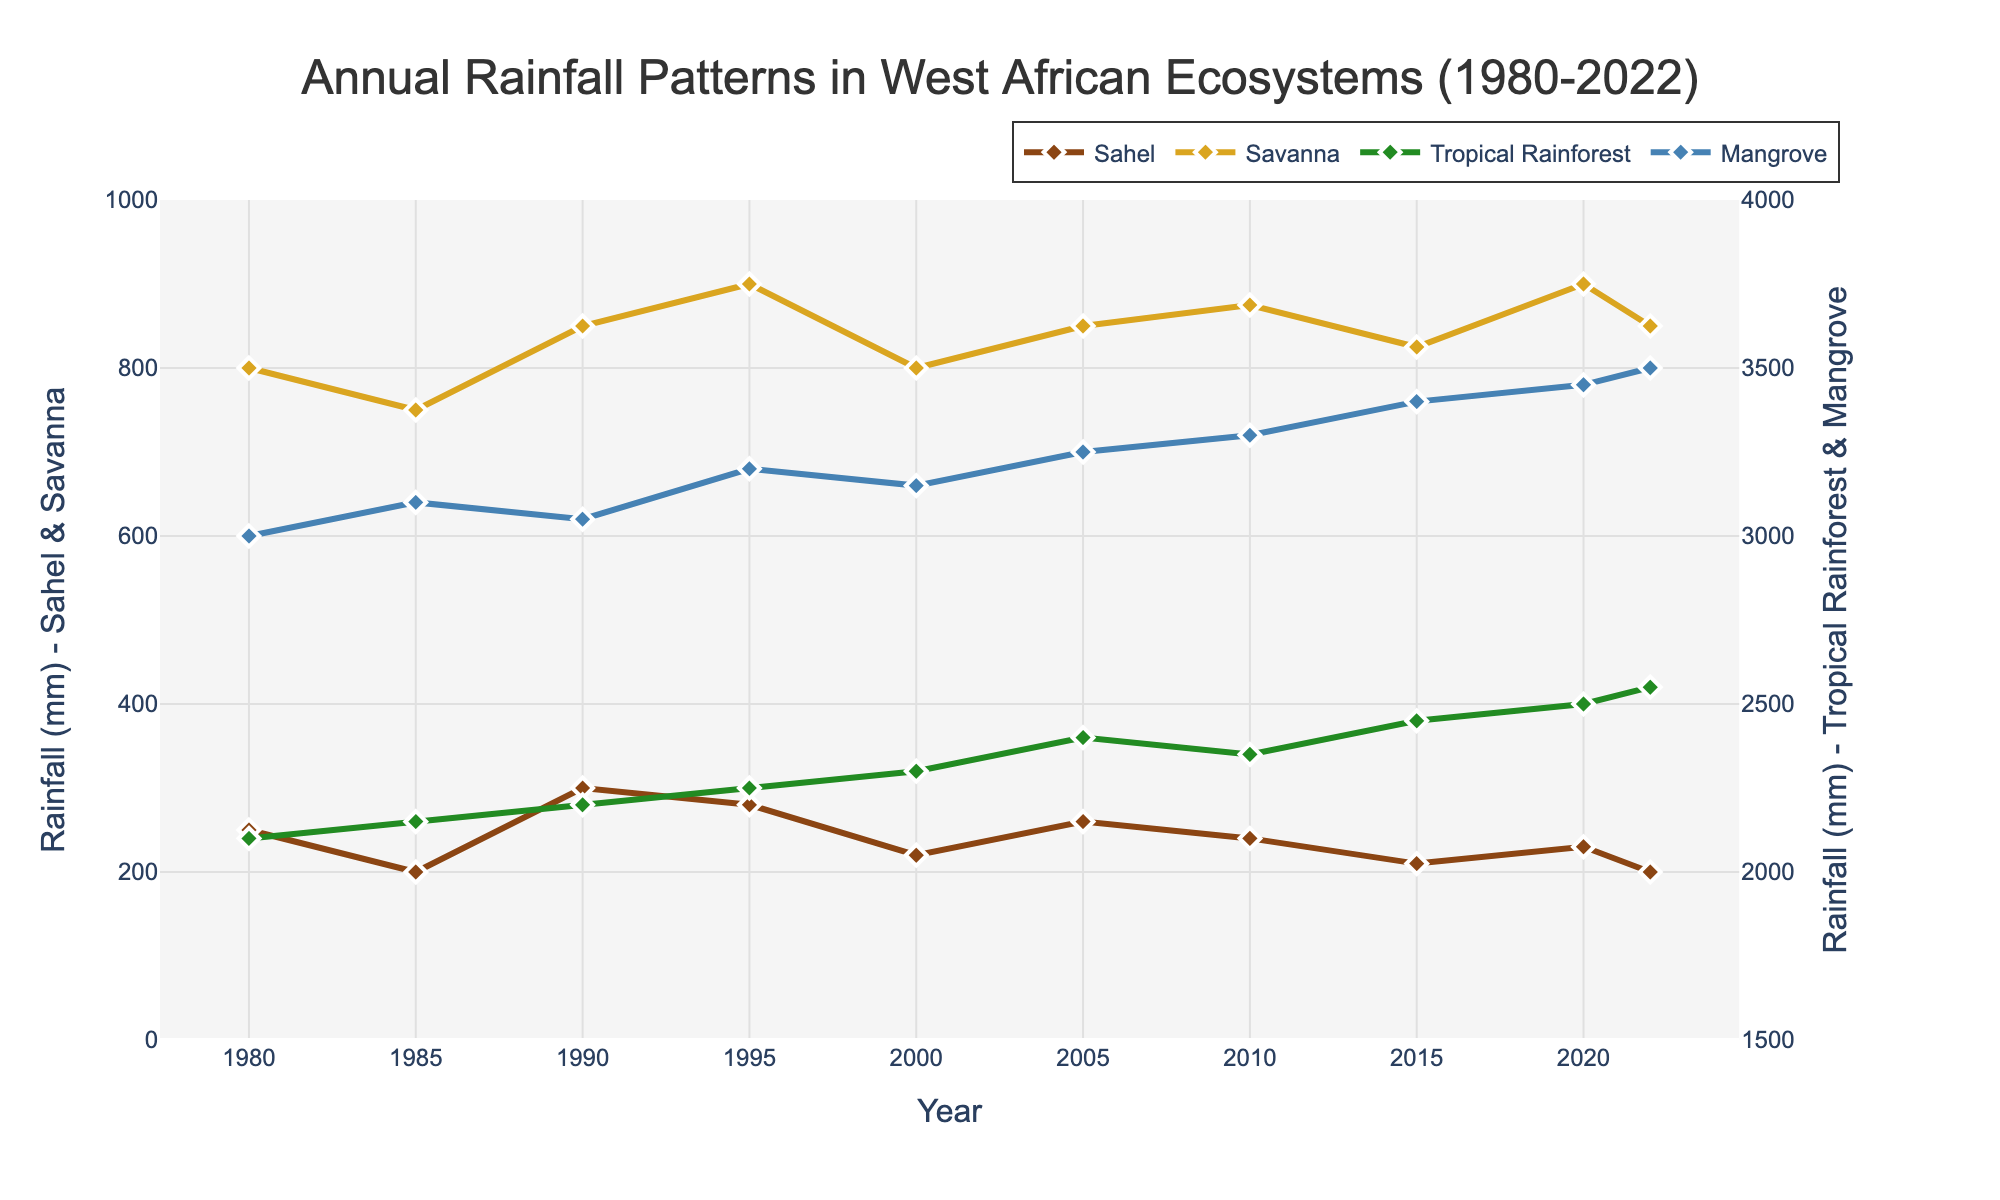What is the trend in the annual rainfall in the Tropical Rainforest ecosystem from 1980 to 2022? The plot shows a consistent increase in rainfall from around 2100 mm in 1980 to 2550 mm in 2022.
Answer: Increase How does the rainfall pattern in the Mangrove ecosystem in 1985 compare to that in 2022? The plot shows the rainfall in the Mangrove ecosystem was 3100 mm in 1985 and increased to 3500 mm in 2022.
Answer: Increased What is the average annual rainfall in the Savanna ecosystem over the period shown? Sum the values of the Savanna rainfall and divide by the total number of data points: (800 + 750 + 850 + 900 + 800 + 850 + 875 + 825 + 900 + 850) / 10 = 8500 / 10 = 850 mm.
Answer: 850 mm Which ecosystem experienced the highest increase in rainfall from 1980 to 2022? Compare the increase: Sahel (250 mm - 200 mm), Savanna (800 mm - 850 mm), Tropical Rainforest (2100 mm - 2550 mm), Mangrove (3000 mm - 3500 mm). Mangrove experienced the highest increase of 500 mm.
Answer: Mangrove In which year did the Savanna ecosystem experience the highest rainfall? By examining the plot, the highest point for Savanna occurs in 1995 with a value of 900 mm.
Answer: 1995 Compare the trend of the Sahel rainfall with that of the Mangrove between 1980 and 2022. The Sahel shows a fluctuation with no clear increasing or decreasing trend, while the Mangrove shows a consistent increase in rainfall over the same period.
Answer: Fluctuating vs Increasing What is the difference in the rainfall in the Tropical Rainforest ecosystem between 2000 and 2022? Subtract the rainfall value of 2000 from the value of 2022: 2550 mm - 2300 mm = 250 mm.
Answer: 250 mm Identify the ecosystem that shows the least variability in annual rainfall from 1980 to 2022. Looking at the plot, the Tropical Rainforest has a consistent upward trend but the changes between years are relatively small compared to Sahel and Savanna.
Answer: Tropical Rainforest Calculate the average increase in rainfall per decade for the Mangrove ecosystem. Calculate the increase for each decade and find the average: (3100 mm - 3000 mm), (3200 mm - 3100 mm), (3250 mm - 3200 mm), (3300 mm - 3250 mm), (3400 mm - 3300 mm), (3450 mm - 3400 mm), (3500 mm - 3450 mm). Average increase = (100 + 100 + 50 + 50 + 100 + 50 + 50) / 7 ~ 71.43 mm/decade.
Answer: ~71.43 mm/decade 